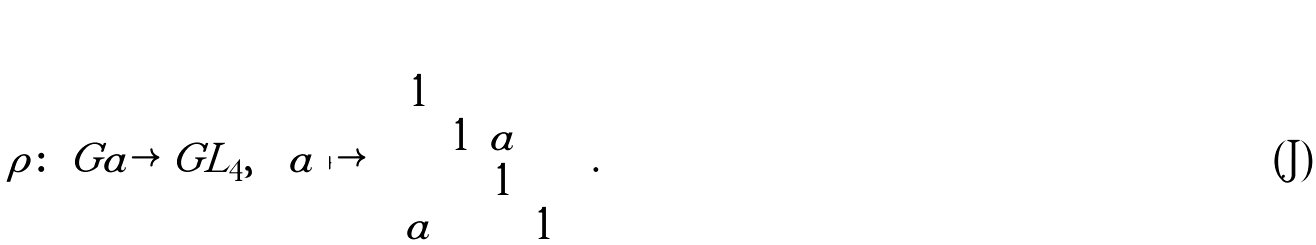<formula> <loc_0><loc_0><loc_500><loc_500>\rho \colon \ G a \rightarrow \ G L _ { 4 } , \quad a \mapsto \left ( \begin{array} { c c c c } 1 & & & \\ & 1 & a & \\ & & 1 \\ a & & & 1 \end{array} \right ) .</formula> 